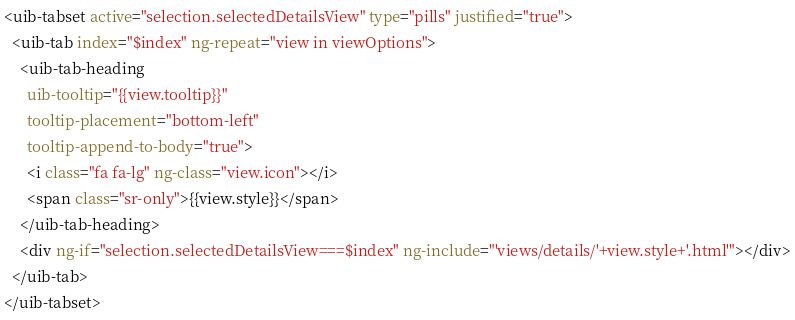<code> <loc_0><loc_0><loc_500><loc_500><_HTML_><uib-tabset active="selection.selectedDetailsView" type="pills" justified="true">
  <uib-tab index="$index" ng-repeat="view in viewOptions">
    <uib-tab-heading
      uib-tooltip="{{view.tooltip}}"
      tooltip-placement="bottom-left"
      tooltip-append-to-body="true">
      <i class="fa fa-lg" ng-class="view.icon"></i>
      <span class="sr-only">{{view.style}}</span>
    </uib-tab-heading>
    <div ng-if="selection.selectedDetailsView===$index" ng-include="'views/details/'+view.style+'.html'"></div>
  </uib-tab>
</uib-tabset>
</code> 